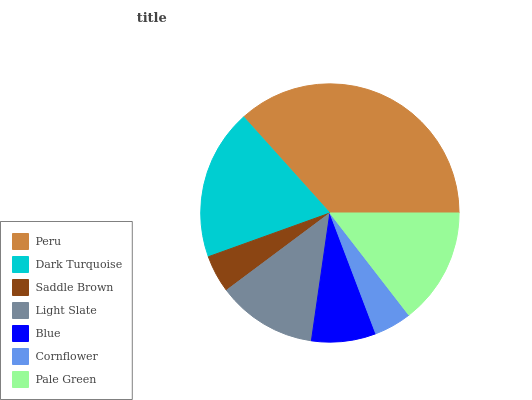Is Cornflower the minimum?
Answer yes or no. Yes. Is Peru the maximum?
Answer yes or no. Yes. Is Dark Turquoise the minimum?
Answer yes or no. No. Is Dark Turquoise the maximum?
Answer yes or no. No. Is Peru greater than Dark Turquoise?
Answer yes or no. Yes. Is Dark Turquoise less than Peru?
Answer yes or no. Yes. Is Dark Turquoise greater than Peru?
Answer yes or no. No. Is Peru less than Dark Turquoise?
Answer yes or no. No. Is Light Slate the high median?
Answer yes or no. Yes. Is Light Slate the low median?
Answer yes or no. Yes. Is Saddle Brown the high median?
Answer yes or no. No. Is Peru the low median?
Answer yes or no. No. 